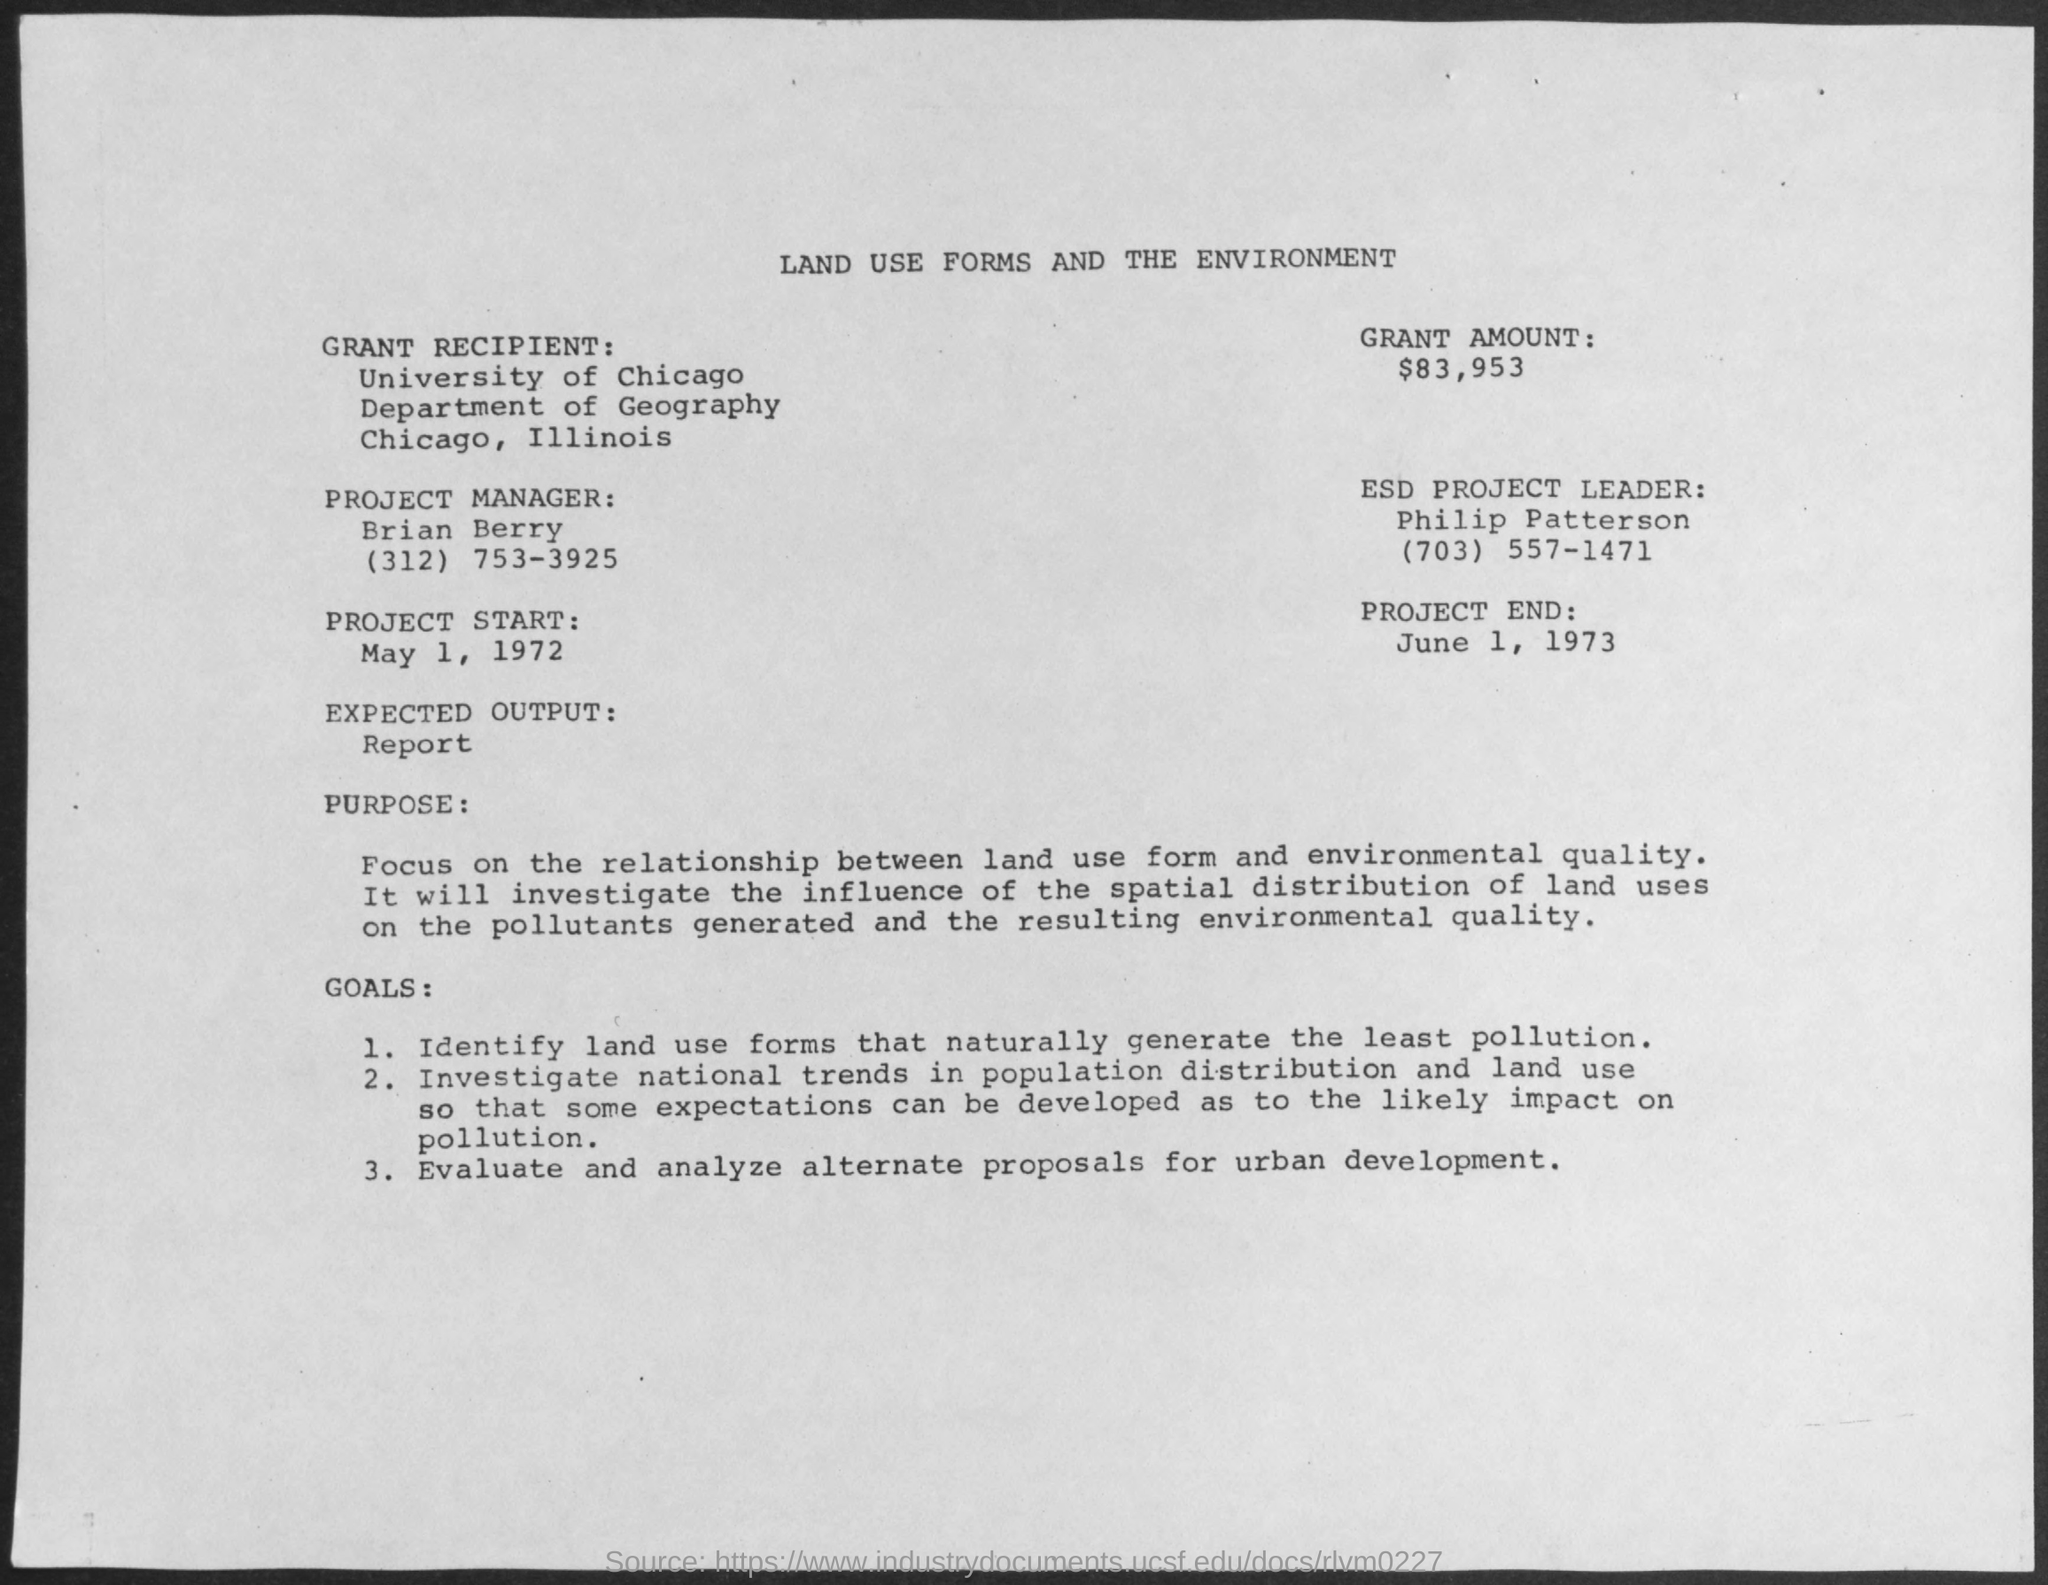Who is the Grant Recipient given in the document?
Provide a succinct answer. University of Chicago. What is the Grant Amount mentioned in the document?
Provide a succinct answer. $83,953. Who is the Project Manager as per the document?
Your response must be concise. Brian Berry. What is the contact no of Brian Berry?
Offer a terse response. (312) 753-3925. Who is the ESD Project Leader as per the document?
Make the answer very short. Philip Patterson. What is the expected output  given in this document?
Offer a terse response. Report. What is the contact no of Philip Patterson?
Offer a very short reply. (703) 557-1471. 